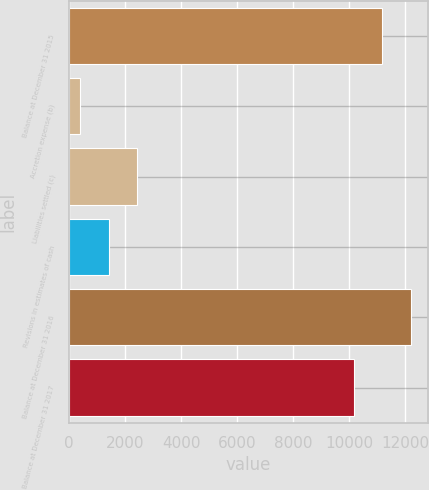Convert chart to OTSL. <chart><loc_0><loc_0><loc_500><loc_500><bar_chart><fcel>Balance at December 31 2015<fcel>Accretion expense (b)<fcel>Liabilities settled (c)<fcel>Revisions in estimates of cash<fcel>Balance at December 31 2016<fcel>Balance at December 31 2017<nl><fcel>11196.1<fcel>400<fcel>2442.2<fcel>1421.1<fcel>12217.2<fcel>10175<nl></chart> 